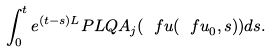Convert formula to latex. <formula><loc_0><loc_0><loc_500><loc_500>\int _ { 0 } ^ { t } e ^ { ( t - s ) L } P L Q A _ { j } ( { \ f u } ( { \ f u } _ { 0 } , s ) ) d s .</formula> 